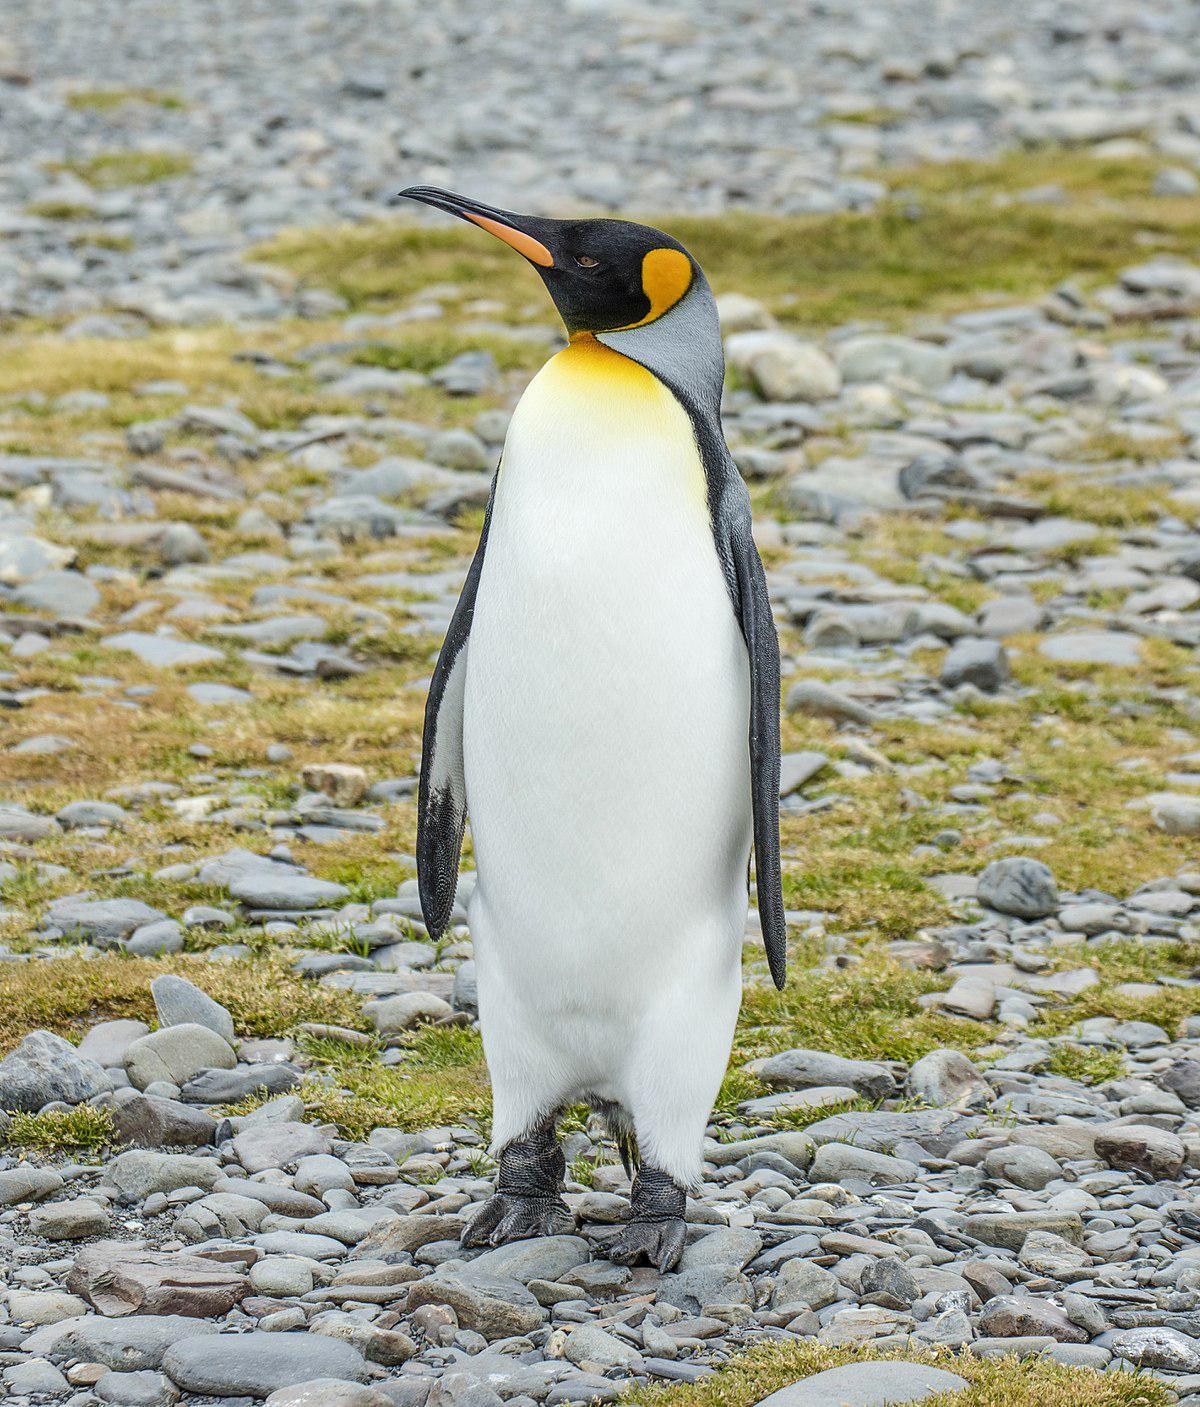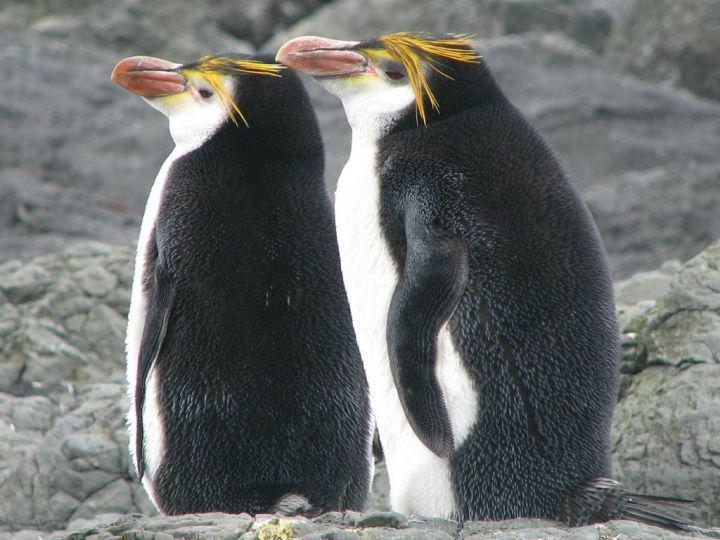The first image is the image on the left, the second image is the image on the right. Analyze the images presented: Is the assertion "There are no more than three penguins standing on the ground." valid? Answer yes or no. Yes. 